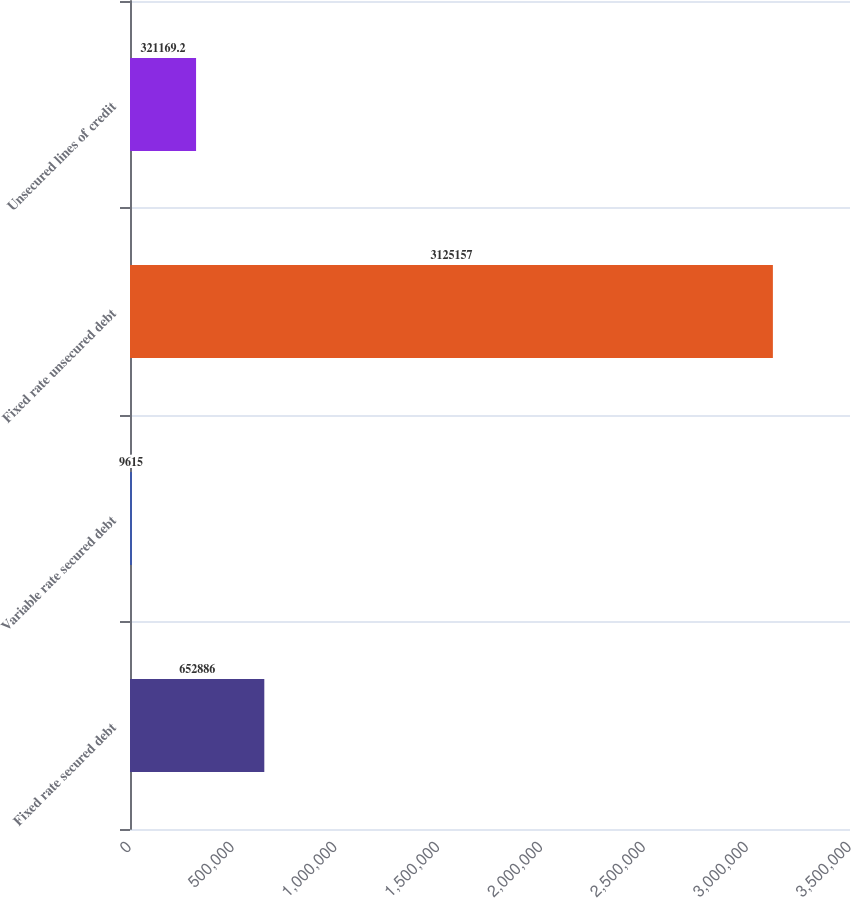Convert chart to OTSL. <chart><loc_0><loc_0><loc_500><loc_500><bar_chart><fcel>Fixed rate secured debt<fcel>Variable rate secured debt<fcel>Fixed rate unsecured debt<fcel>Unsecured lines of credit<nl><fcel>652886<fcel>9615<fcel>3.12516e+06<fcel>321169<nl></chart> 